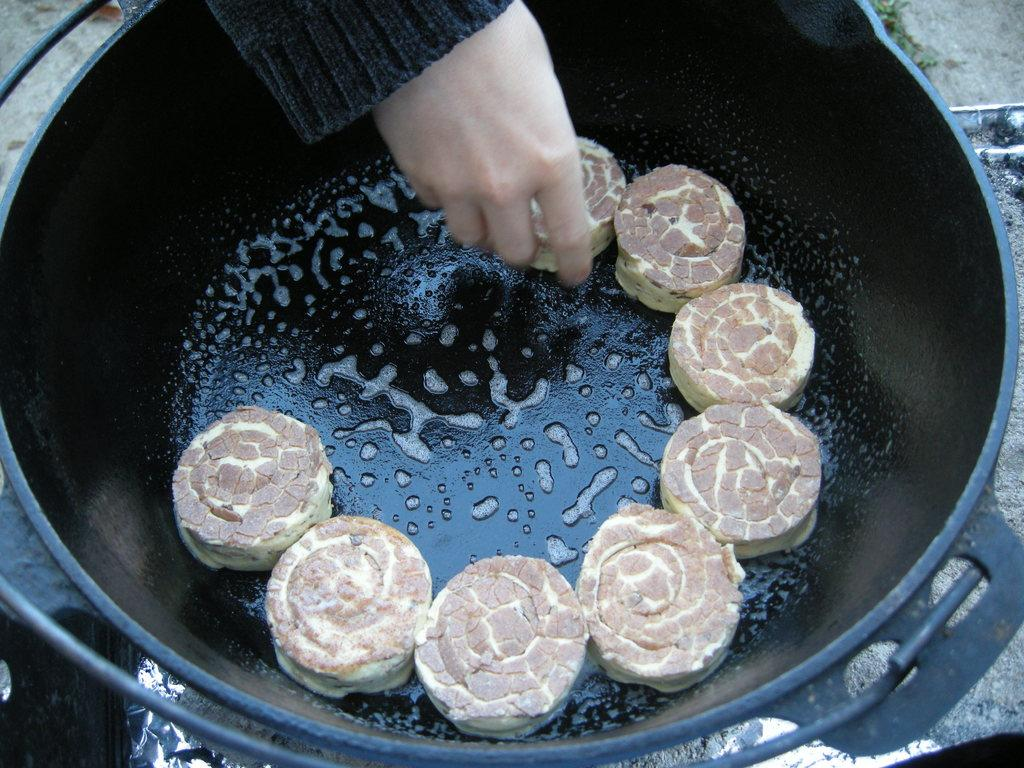What is inside the container that is visible in the image? There is food in a container in the image. Can you describe any other elements in the image besides the container? A hand of a person is visible at the top of the image. What type of flower can be seen growing in the container in the image? There is no flower present in the container; it contains food. 